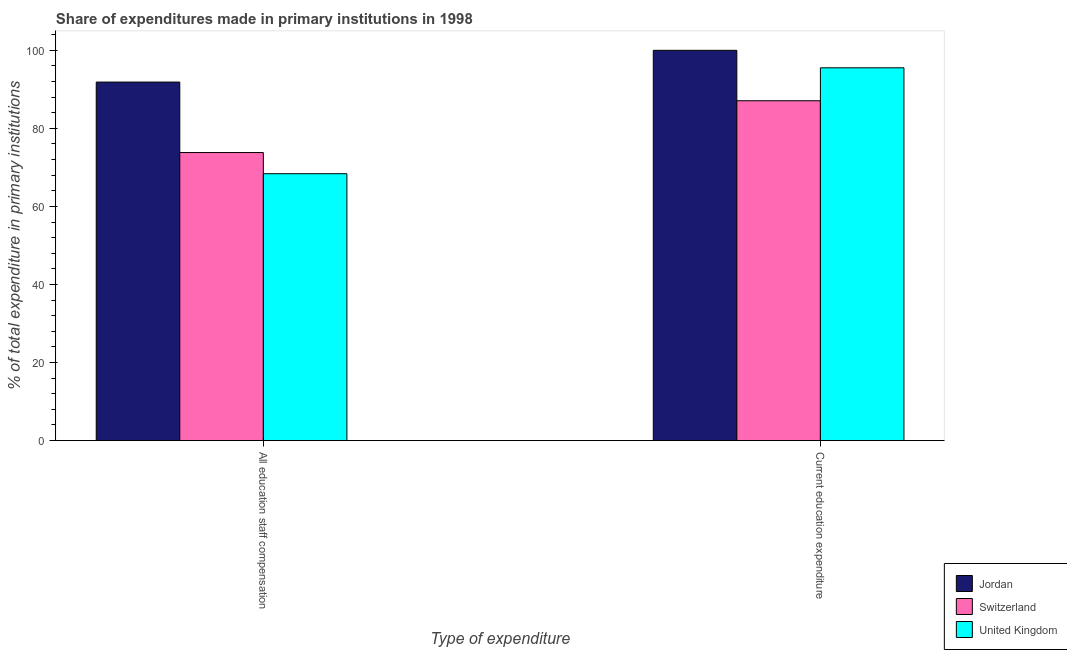How many different coloured bars are there?
Make the answer very short. 3. How many groups of bars are there?
Offer a terse response. 2. How many bars are there on the 1st tick from the right?
Your answer should be compact. 3. What is the label of the 1st group of bars from the left?
Offer a terse response. All education staff compensation. What is the expenditure in education in Switzerland?
Give a very brief answer. 87.08. Across all countries, what is the maximum expenditure in staff compensation?
Your answer should be very brief. 91.87. Across all countries, what is the minimum expenditure in education?
Provide a short and direct response. 87.08. In which country was the expenditure in education maximum?
Make the answer very short. Jordan. What is the total expenditure in staff compensation in the graph?
Ensure brevity in your answer.  234.06. What is the difference between the expenditure in staff compensation in United Kingdom and that in Switzerland?
Offer a terse response. -5.42. What is the difference between the expenditure in staff compensation in Switzerland and the expenditure in education in United Kingdom?
Your answer should be very brief. -21.72. What is the average expenditure in staff compensation per country?
Provide a succinct answer. 78.02. What is the difference between the expenditure in staff compensation and expenditure in education in Jordan?
Give a very brief answer. -8.13. What is the ratio of the expenditure in staff compensation in United Kingdom to that in Switzerland?
Offer a terse response. 0.93. In how many countries, is the expenditure in staff compensation greater than the average expenditure in staff compensation taken over all countries?
Your answer should be compact. 1. What does the 2nd bar from the left in All education staff compensation represents?
Give a very brief answer. Switzerland. What does the 1st bar from the right in Current education expenditure represents?
Provide a short and direct response. United Kingdom. How many bars are there?
Keep it short and to the point. 6. Are all the bars in the graph horizontal?
Ensure brevity in your answer.  No. How many countries are there in the graph?
Your answer should be very brief. 3. Are the values on the major ticks of Y-axis written in scientific E-notation?
Provide a short and direct response. No. Does the graph contain any zero values?
Your answer should be very brief. No. Where does the legend appear in the graph?
Keep it short and to the point. Bottom right. How many legend labels are there?
Your answer should be compact. 3. What is the title of the graph?
Your response must be concise. Share of expenditures made in primary institutions in 1998. What is the label or title of the X-axis?
Your response must be concise. Type of expenditure. What is the label or title of the Y-axis?
Provide a succinct answer. % of total expenditure in primary institutions. What is the % of total expenditure in primary institutions of Jordan in All education staff compensation?
Provide a succinct answer. 91.87. What is the % of total expenditure in primary institutions in Switzerland in All education staff compensation?
Provide a short and direct response. 73.81. What is the % of total expenditure in primary institutions of United Kingdom in All education staff compensation?
Offer a terse response. 68.38. What is the % of total expenditure in primary institutions of Jordan in Current education expenditure?
Keep it short and to the point. 100. What is the % of total expenditure in primary institutions in Switzerland in Current education expenditure?
Keep it short and to the point. 87.08. What is the % of total expenditure in primary institutions of United Kingdom in Current education expenditure?
Give a very brief answer. 95.52. Across all Type of expenditure, what is the maximum % of total expenditure in primary institutions in Switzerland?
Your response must be concise. 87.08. Across all Type of expenditure, what is the maximum % of total expenditure in primary institutions of United Kingdom?
Ensure brevity in your answer.  95.52. Across all Type of expenditure, what is the minimum % of total expenditure in primary institutions of Jordan?
Your response must be concise. 91.87. Across all Type of expenditure, what is the minimum % of total expenditure in primary institutions in Switzerland?
Make the answer very short. 73.81. Across all Type of expenditure, what is the minimum % of total expenditure in primary institutions in United Kingdom?
Make the answer very short. 68.38. What is the total % of total expenditure in primary institutions in Jordan in the graph?
Your answer should be compact. 191.87. What is the total % of total expenditure in primary institutions in Switzerland in the graph?
Your response must be concise. 160.89. What is the total % of total expenditure in primary institutions of United Kingdom in the graph?
Offer a terse response. 163.91. What is the difference between the % of total expenditure in primary institutions in Jordan in All education staff compensation and that in Current education expenditure?
Offer a very short reply. -8.13. What is the difference between the % of total expenditure in primary institutions in Switzerland in All education staff compensation and that in Current education expenditure?
Your answer should be very brief. -13.27. What is the difference between the % of total expenditure in primary institutions of United Kingdom in All education staff compensation and that in Current education expenditure?
Give a very brief answer. -27.14. What is the difference between the % of total expenditure in primary institutions of Jordan in All education staff compensation and the % of total expenditure in primary institutions of Switzerland in Current education expenditure?
Offer a terse response. 4.79. What is the difference between the % of total expenditure in primary institutions of Jordan in All education staff compensation and the % of total expenditure in primary institutions of United Kingdom in Current education expenditure?
Offer a terse response. -3.65. What is the difference between the % of total expenditure in primary institutions of Switzerland in All education staff compensation and the % of total expenditure in primary institutions of United Kingdom in Current education expenditure?
Your answer should be very brief. -21.72. What is the average % of total expenditure in primary institutions of Jordan per Type of expenditure?
Provide a short and direct response. 95.93. What is the average % of total expenditure in primary institutions of Switzerland per Type of expenditure?
Make the answer very short. 80.44. What is the average % of total expenditure in primary institutions in United Kingdom per Type of expenditure?
Your response must be concise. 81.95. What is the difference between the % of total expenditure in primary institutions in Jordan and % of total expenditure in primary institutions in Switzerland in All education staff compensation?
Offer a very short reply. 18.06. What is the difference between the % of total expenditure in primary institutions in Jordan and % of total expenditure in primary institutions in United Kingdom in All education staff compensation?
Make the answer very short. 23.49. What is the difference between the % of total expenditure in primary institutions of Switzerland and % of total expenditure in primary institutions of United Kingdom in All education staff compensation?
Offer a terse response. 5.42. What is the difference between the % of total expenditure in primary institutions in Jordan and % of total expenditure in primary institutions in Switzerland in Current education expenditure?
Make the answer very short. 12.92. What is the difference between the % of total expenditure in primary institutions in Jordan and % of total expenditure in primary institutions in United Kingdom in Current education expenditure?
Keep it short and to the point. 4.48. What is the difference between the % of total expenditure in primary institutions of Switzerland and % of total expenditure in primary institutions of United Kingdom in Current education expenditure?
Your answer should be very brief. -8.45. What is the ratio of the % of total expenditure in primary institutions of Jordan in All education staff compensation to that in Current education expenditure?
Ensure brevity in your answer.  0.92. What is the ratio of the % of total expenditure in primary institutions in Switzerland in All education staff compensation to that in Current education expenditure?
Your answer should be very brief. 0.85. What is the ratio of the % of total expenditure in primary institutions of United Kingdom in All education staff compensation to that in Current education expenditure?
Provide a succinct answer. 0.72. What is the difference between the highest and the second highest % of total expenditure in primary institutions of Jordan?
Ensure brevity in your answer.  8.13. What is the difference between the highest and the second highest % of total expenditure in primary institutions in Switzerland?
Provide a short and direct response. 13.27. What is the difference between the highest and the second highest % of total expenditure in primary institutions of United Kingdom?
Offer a terse response. 27.14. What is the difference between the highest and the lowest % of total expenditure in primary institutions of Jordan?
Offer a very short reply. 8.13. What is the difference between the highest and the lowest % of total expenditure in primary institutions of Switzerland?
Offer a terse response. 13.27. What is the difference between the highest and the lowest % of total expenditure in primary institutions in United Kingdom?
Provide a short and direct response. 27.14. 